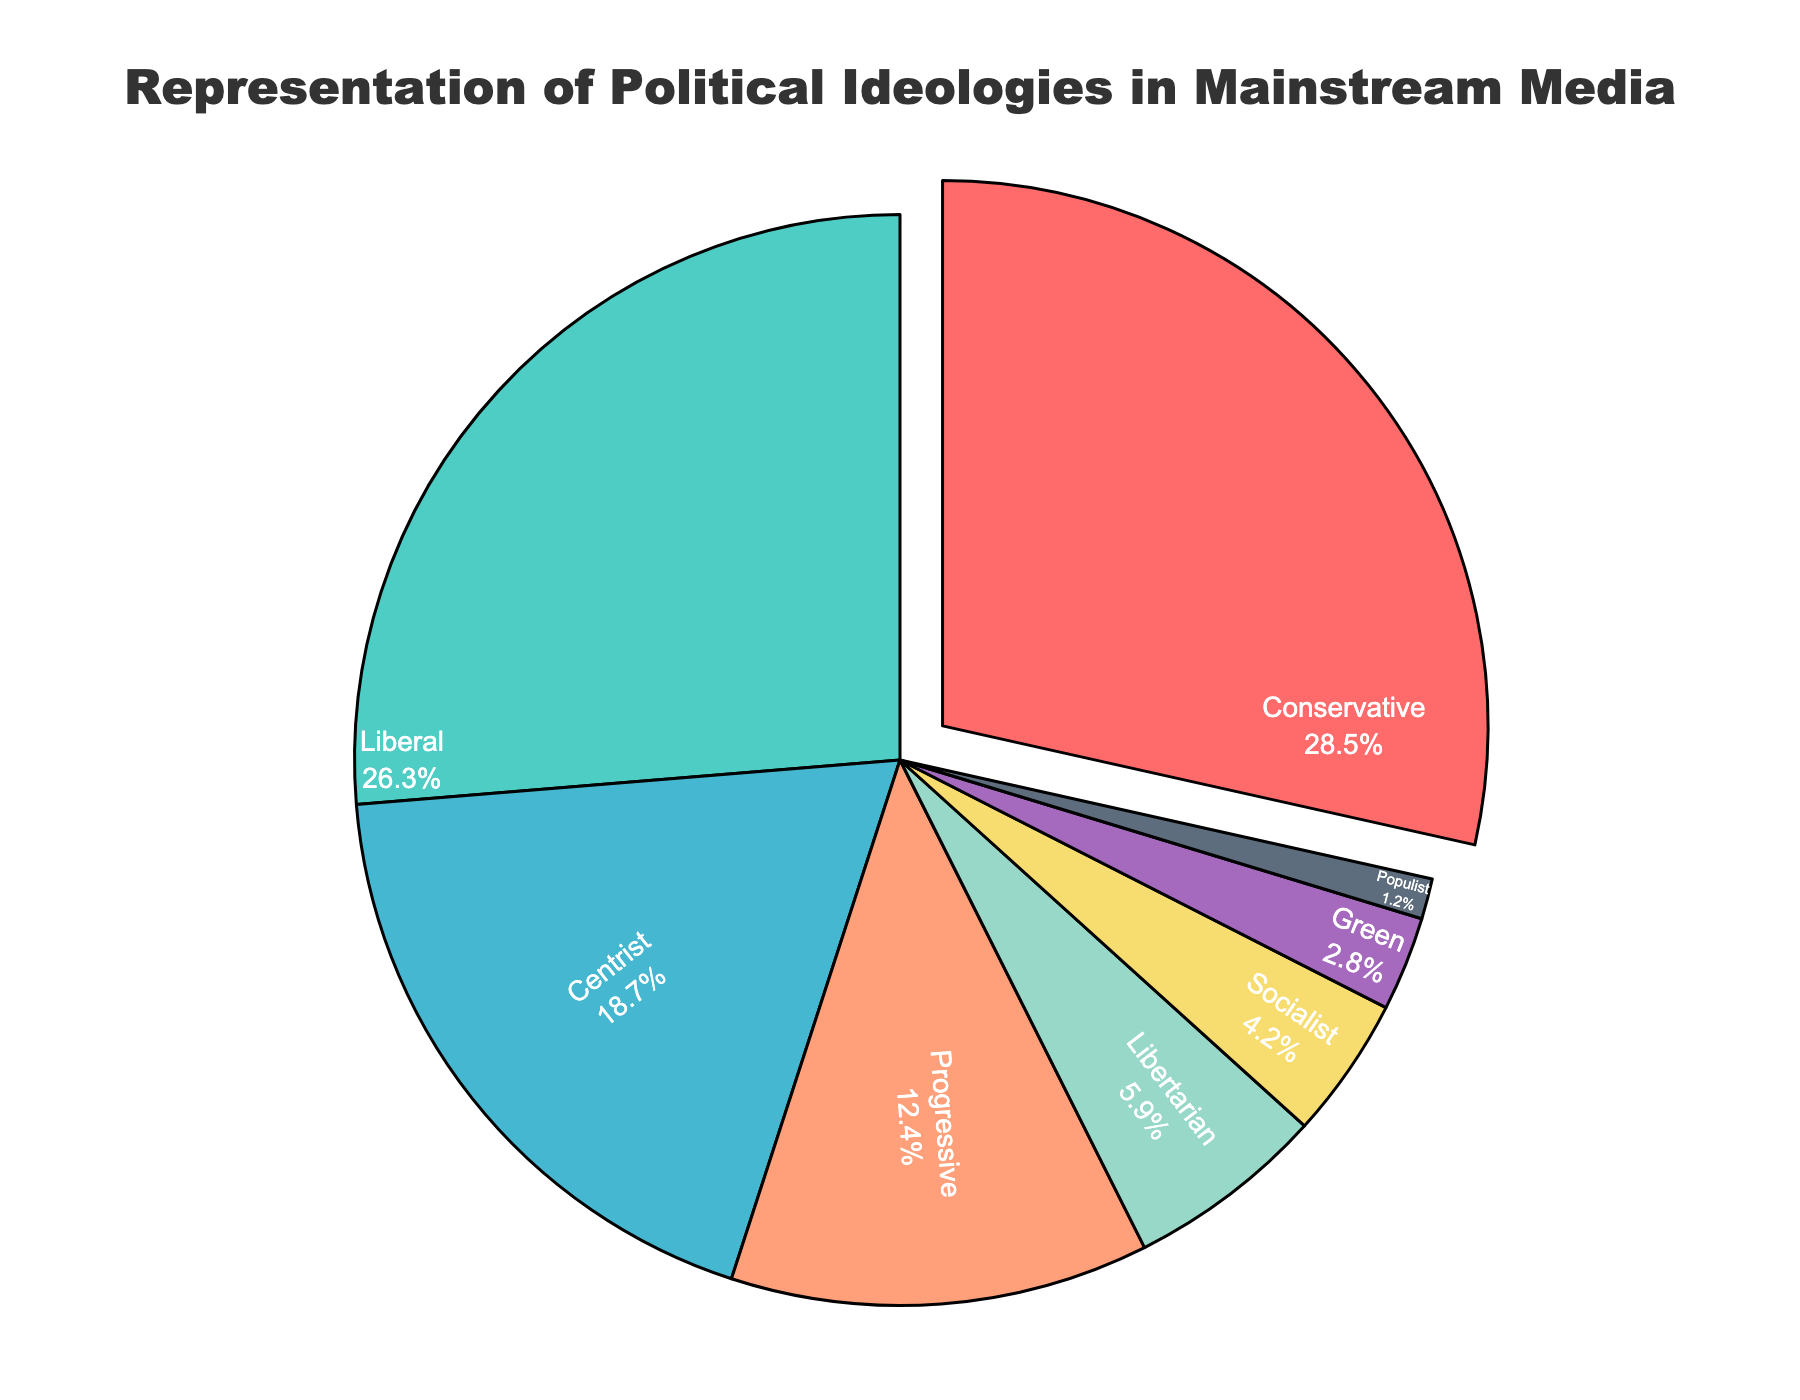What percentage of media coverage is dedicated to Conservative and Liberal ideologies combined? To find the combined media coverage percentage for Conservative and Liberal ideologies, sum their individual percentages. Conservative has 28.5%, and Liberal has 26.3%, so together it's 28.5 + 26.3 = 54.8%.
Answer: 54.8% Which ideology has the highest representation in the mainstream media coverage? The pie chart visually emphasizes the ideology with the highest percentage by pulling its section out slightly. The largest section, which is pulled out, is labeled Conservative with 28.5%.
Answer: Conservative Is the media coverage more equally distributed among Conservative, Liberal, and Centrist ideologies or among Progressive, Socialist, and Green ideologies? To compare the distribution, we need to look at the percentage values for the ideologies. Conservative (28.5%), Liberal (26.3%), and Centrist (18.7%) have percentages closer to each other, while Progressive (12.4%), Socialist (4.2%), and Green (2.8%) have more variance in their percentages, making the first group more equally distributed.
Answer: Conservative, Liberal, and Centrist Which ideology accounts for less than 10% of media coverage but more than 5%? By examining the percentages, we can see that Libertarian is the only ideology that fits this range with 5.9%.
Answer: Libertarian What is the difference in media coverage percentage between the Green and the Centrist ideologies? To find the difference, subtract the percentage of Green ideology from the Centrist ideology. Centrist has 18.7%, and Green has 2.8%, so the difference is 18.7 - 2.8 = 15.9%.
Answer: 15.9% If you sum up the percentages for Progressive, Socialist, Green, and Populist ideologies, what is their total media coverage? Add the percentages of the four ideologies: Progressive (12.4%), Socialist (4.2%), Green (2.8%), and Populist (1.2%). Their total is 12.4 + 4.2 + 2.8 + 1.2 = 20.6%.
Answer: 20.6% Which ideology has a slice colored in green in the pie chart? Green colors are usually recognized visually in the pie chart. The Green ideology piece is colored green and is labeled with 2.8%.
Answer: Green How does the media coverage of Progressive ideology compare with that of Libertarian ideology? Look at both percentages; Progressive has 12.4% and Libertarian has 5.9%. Progressive has a higher media coverage percentage.
Answer: Progressive is higher What is the average media coverage for Centrist, Progressive, and Libertarian ideologies? To find the average, add the percentages of Centrist (18.7%), Progressive (12.4%), and Libertarian (5.9%) and then divide by 3. The sum is 18.7 + 12.4 + 5.9 = 37, and the average is 37 / 3 ≈ 12.33%.
Answer: 12.33% Which ideologies combined make up more than half of the total media coverage? Sum the percentages of the ideologies starting with the largest ones until you exceed 50%. Conservative (28.5%) and Liberal (26.3%) together sum to 54.8%, exceeding 50%.
Answer: Conservative and Liberal 